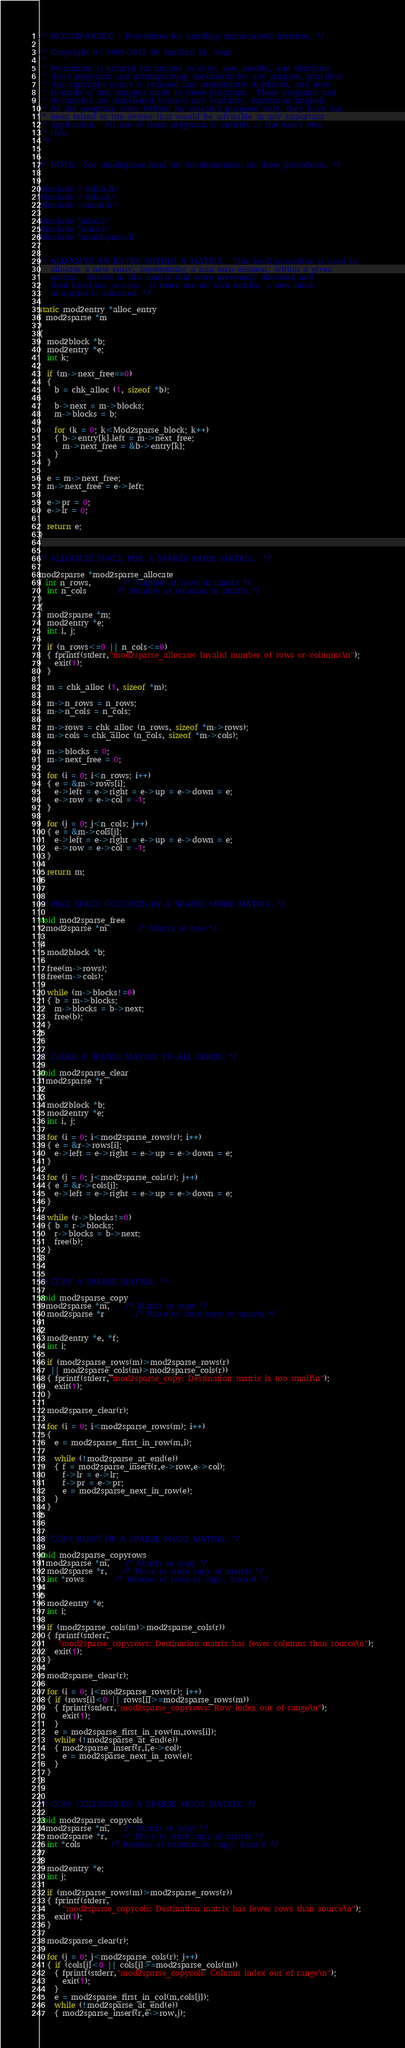Convert code to text. <code><loc_0><loc_0><loc_500><loc_500><_C_>/* MOD2SPARSE.C - Procedures for handling sparse mod2 matrices. */

/* Copyright (c) 1995-2012 by Radford M. Neal.
 *
 * Permission is granted for anyone to copy, use, modify, and distribute
 * these programs and accompanying documents for any purpose, provided
 * this copyright notice is retained and prominently displayed, and note
 * is made of any changes made to these programs.  These programs and
 * documents are distributed without any warranty, express or implied.
 * As the programs were written for research purposes only, they have not
 * been tested to the degree that would be advisable in any important
 * application.  All use of these programs is entirely at the user's own
 * risk.
 */


/* NOTE:  See mod2sparse.html for documentation on these procedures. */


#include <stdlib.h>
#include <stdio.h>
#include <math.h>

#include "alloc.h"
#include "intio.h"
#include "mod2sparse.h"


/* ALLOCATE AN ENTRY WITHIN A MATRIX.  This local procedure is used to
   allocate a new entry, representing a non-zero element, within a given
   matrix.  Entries in this matrix that were previously allocated and
   then freed are re-used.  If there are no such entries, a new block
   of entries is allocated. */

static mod2entry *alloc_entry
( mod2sparse *m
)
{ 
  mod2block *b;
  mod2entry *e;
  int k;

  if (m->next_free==0)
  { 
    b = chk_alloc (1, sizeof *b);

    b->next = m->blocks;
    m->blocks = b;

    for (k = 0; k<Mod2sparse_block; k++)
    { b->entry[k].left = m->next_free;
      m->next_free = &b->entry[k];
    }
  }

  e = m->next_free;
  m->next_free = e->left;

  e->pr = 0;
  e->lr = 0;

  return e;
}


/* ALLOCATE SPACE FOR A SPARSE MOD2 MATRIX.  */

mod2sparse *mod2sparse_allocate
( int n_rows, 		/* Number of rows in matrix */
  int n_cols		/* Number of columns in matrix */
)
{
  mod2sparse *m;
  mod2entry *e;
  int i, j;

  if (n_rows<=0 || n_cols<=0)
  { fprintf(stderr,"mod2sparse_allocate: Invalid number of rows or columns\n");
    exit(1);
  }

  m = chk_alloc (1, sizeof *m);

  m->n_rows = n_rows;
  m->n_cols = n_cols;

  m->rows = chk_alloc (n_rows, sizeof *m->rows);
  m->cols = chk_alloc (n_cols, sizeof *m->cols);

  m->blocks = 0;
  m->next_free = 0;

  for (i = 0; i<n_rows; i++)
  { e = &m->rows[i];
    e->left = e->right = e->up = e->down = e;
    e->row = e->col = -1;
  }

  for (j = 0; j<n_cols; j++)
  { e = &m->cols[j];
    e->left = e->right = e->up = e->down = e;
    e->row = e->col = -1;
  }

  return m;
}


/* FREE SPACE OCCUPIED BY A SPARSE MOD2 MATRIX. */

void mod2sparse_free
( mod2sparse *m		/* Matrix to free */
)
{ 
  mod2block *b;

  free(m->rows);
  free(m->cols);

  while (m->blocks!=0)
  { b = m->blocks;
    m->blocks = b->next;
    free(b);
  }
}


/* CLEAR A SPARSE MATRIX TO ALL ZEROS. */

void mod2sparse_clear
( mod2sparse *r
)
{
  mod2block *b;
  mod2entry *e;
  int i, j;

  for (i = 0; i<mod2sparse_rows(r); i++)
  { e = &r->rows[i];
    e->left = e->right = e->up = e->down = e;
  }

  for (j = 0; j<mod2sparse_cols(r); j++)
  { e = &r->cols[j];
    e->left = e->right = e->up = e->down = e;
  }

  while (r->blocks!=0)
  { b = r->blocks;
    r->blocks = b->next;
    free(b);
  }
}


/* COPY A SPARSE MATRIX. */

void mod2sparse_copy
( mod2sparse *m,	/* Matrix to copy */
  mod2sparse *r		/* Place to store copy of matrix */
)
{
  mod2entry *e, *f;
  int i;

  if (mod2sparse_rows(m)>mod2sparse_rows(r) 
   || mod2sparse_cols(m)>mod2sparse_cols(r))
  { fprintf(stderr,"mod2sparse_copy: Destination matrix is too small\n");
    exit(1);
  }

  mod2sparse_clear(r);

  for (i = 0; i<mod2sparse_rows(m); i++)
  {
    e = mod2sparse_first_in_row(m,i); 

    while (!mod2sparse_at_end(e))
    { f = mod2sparse_insert(r,e->row,e->col);
      f->lr = e->lr;
      f->pr = e->pr;
      e = mod2sparse_next_in_row(e);
    }
  }
}


/* COPY ROWS OF A SPARSE MOD2 MATRIX. */

void mod2sparse_copyrows
( mod2sparse *m,	/* Matrix to copy */
  mod2sparse *r,	/* Place to store copy of matrix */
  int *rows		/* Indexes of rows to copy, from 0 */
)
{ 
  mod2entry *e;
  int i;

  if (mod2sparse_cols(m)>mod2sparse_cols(r))
  { fprintf(stderr,
     "mod2sparse_copyrows: Destination matrix has fewer columns than source\n");
    exit(1);
  }

  mod2sparse_clear(r);

  for (i = 0; i<mod2sparse_rows(r); i++)
  { if (rows[i]<0 || rows[i]>=mod2sparse_rows(m))
    { fprintf(stderr,"mod2sparse_copyrows: Row index out of range\n");
      exit(1);
    }
    e = mod2sparse_first_in_row(m,rows[i]);
    while (!mod2sparse_at_end(e))
    { mod2sparse_insert(r,i,e->col);
      e = mod2sparse_next_in_row(e);
    }
  }
}


/* COPY COLUMNS OF A SPARSE MOD2 MATRIX. */

void mod2sparse_copycols
( mod2sparse *m,	/* Matrix to copy */
  mod2sparse *r,	/* Place to store copy of matrix */
  int *cols		/* Indexes of columns to copy, from 0 */
)
{ 
  mod2entry *e;
  int j;

  if (mod2sparse_rows(m)>mod2sparse_rows(r))
  { fprintf(stderr,
      "mod2sparse_copycols: Destination matrix has fewer rows than source\n");
    exit(1);
  }

  mod2sparse_clear(r);

  for (j = 0; j<mod2sparse_cols(r); j++)
  { if (cols[j]<0 || cols[j]>=mod2sparse_cols(m))
    { fprintf(stderr,"mod2sparse_copycols: Column index out of range\n");
      exit(1);
    }
    e = mod2sparse_first_in_col(m,cols[j]);
    while (!mod2sparse_at_end(e))
    { mod2sparse_insert(r,e->row,j);</code> 